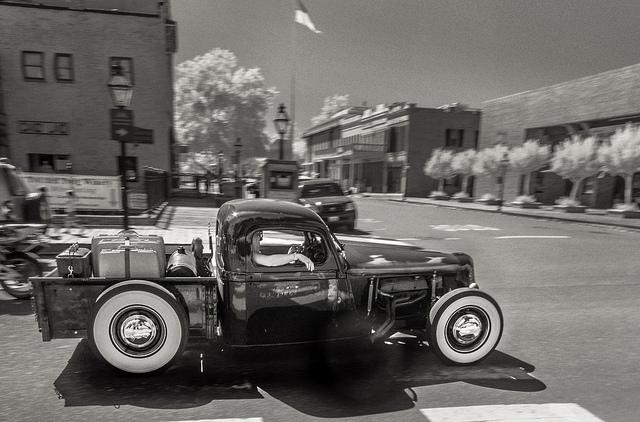How many flags are there?
Quick response, please. 1. Is it day time?
Be succinct. Yes. Is this a modern vehicle?
Write a very short answer. No. 